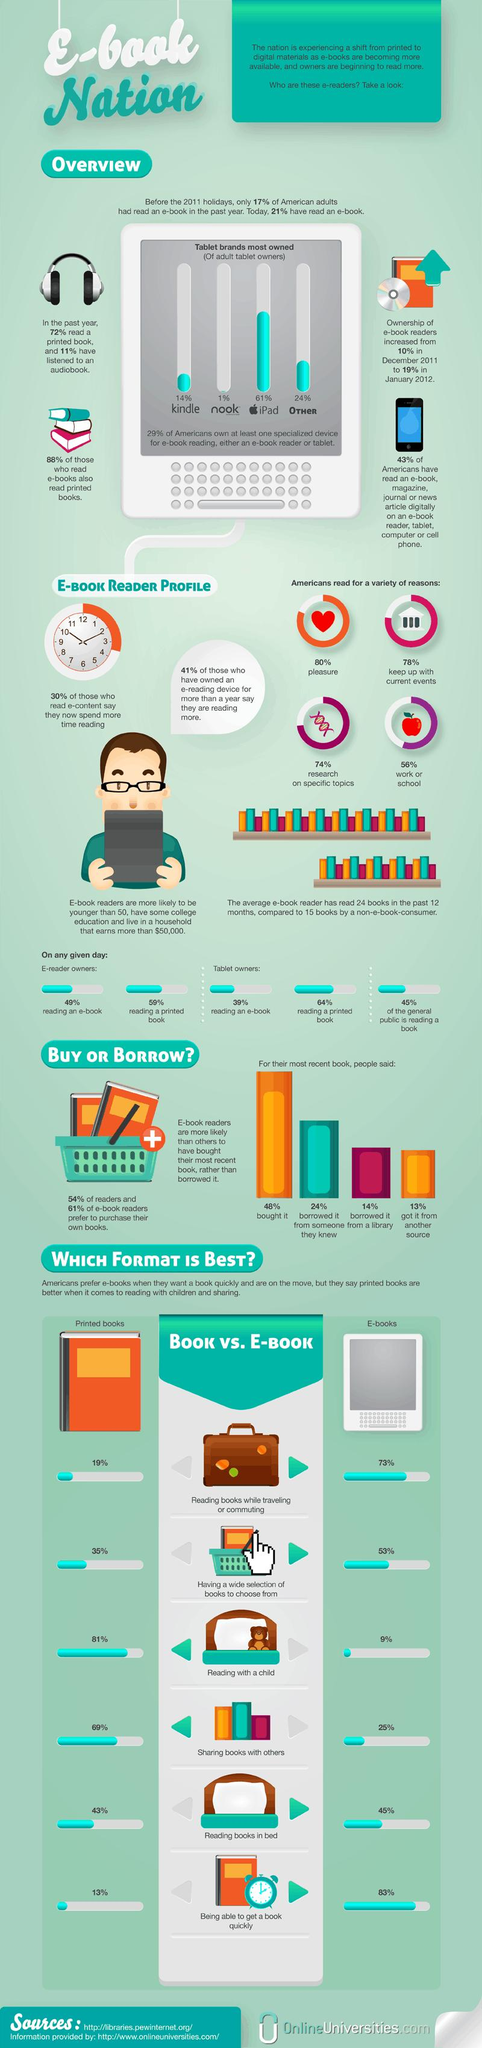Draw attention to some important aspects in this diagram. It is estimated that 15% of Americans own both a Kindle and a Nook for the purpose of e-book reading. E-books are the best format for reading books while traveling or commuting because they are portable, lightweight, and can be easily accessed on electronic devices. According to a recent survey, 26% of Americans do not read for pleasure. E-books are the best format for reading books in bed. In the United States, approximately 20% of the population do not engage in reading for pleasure. 